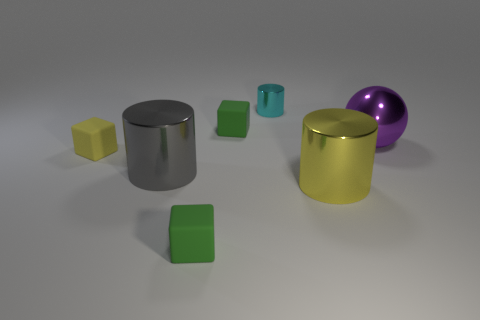Add 3 metal cubes. How many objects exist? 10 Subtract all cylinders. How many objects are left? 4 Add 4 big gray rubber balls. How many big gray rubber balls exist? 4 Subtract 1 yellow cylinders. How many objects are left? 6 Subtract all small red rubber cylinders. Subtract all rubber blocks. How many objects are left? 4 Add 5 large purple metallic spheres. How many large purple metallic spheres are left? 6 